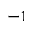<formula> <loc_0><loc_0><loc_500><loc_500>^ { - 1 }</formula> 